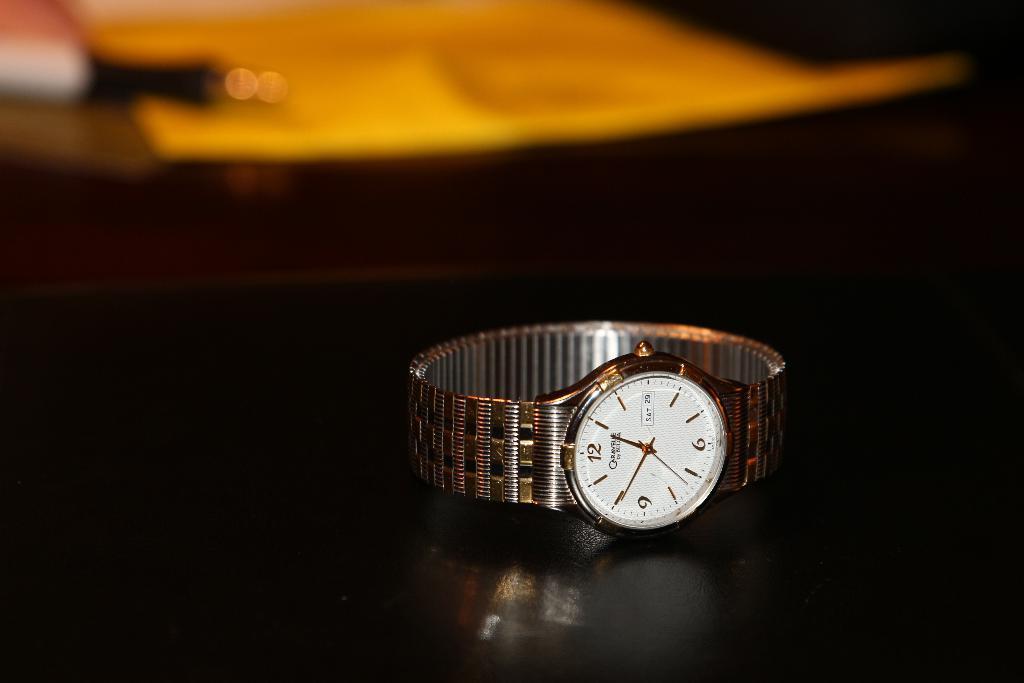Can you describe this image briefly? In the front of the image there is a wrist watch on the black surface. In the background of the image it is blurry and there are objects. 